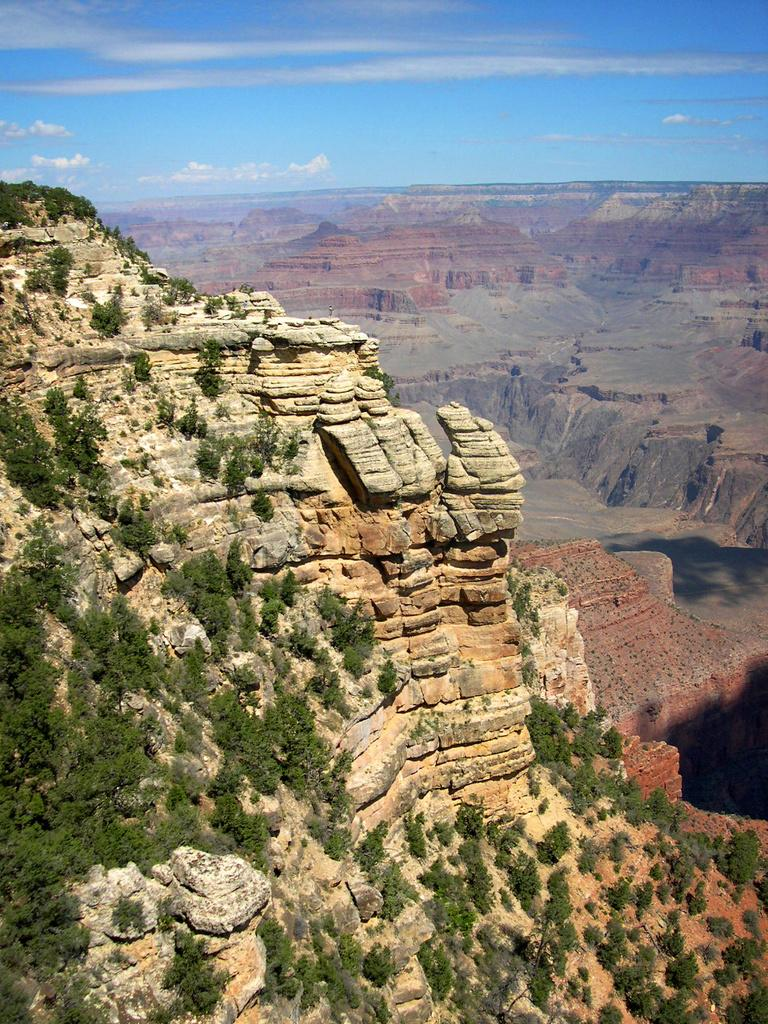What type of natural landscape is depicted in the image? The image features hills, trees, and rocks, indicating a natural landscape. Can you describe the vegetation in the image? There are trees visible in the image. Are there any geological features present in the image? Yes, there are rocks in the image. What is visible at the top of the image? Clouds are visible at the top of the image. What type of feather can be seen on the donkey in the image? There is no donkey or feather present in the image; it features a natural landscape with hills, trees, rocks, and clouds. How many ears of corn are visible in the image? There are no ears of corn present in the image. 